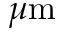<formula> <loc_0><loc_0><loc_500><loc_500>\mu m</formula> 